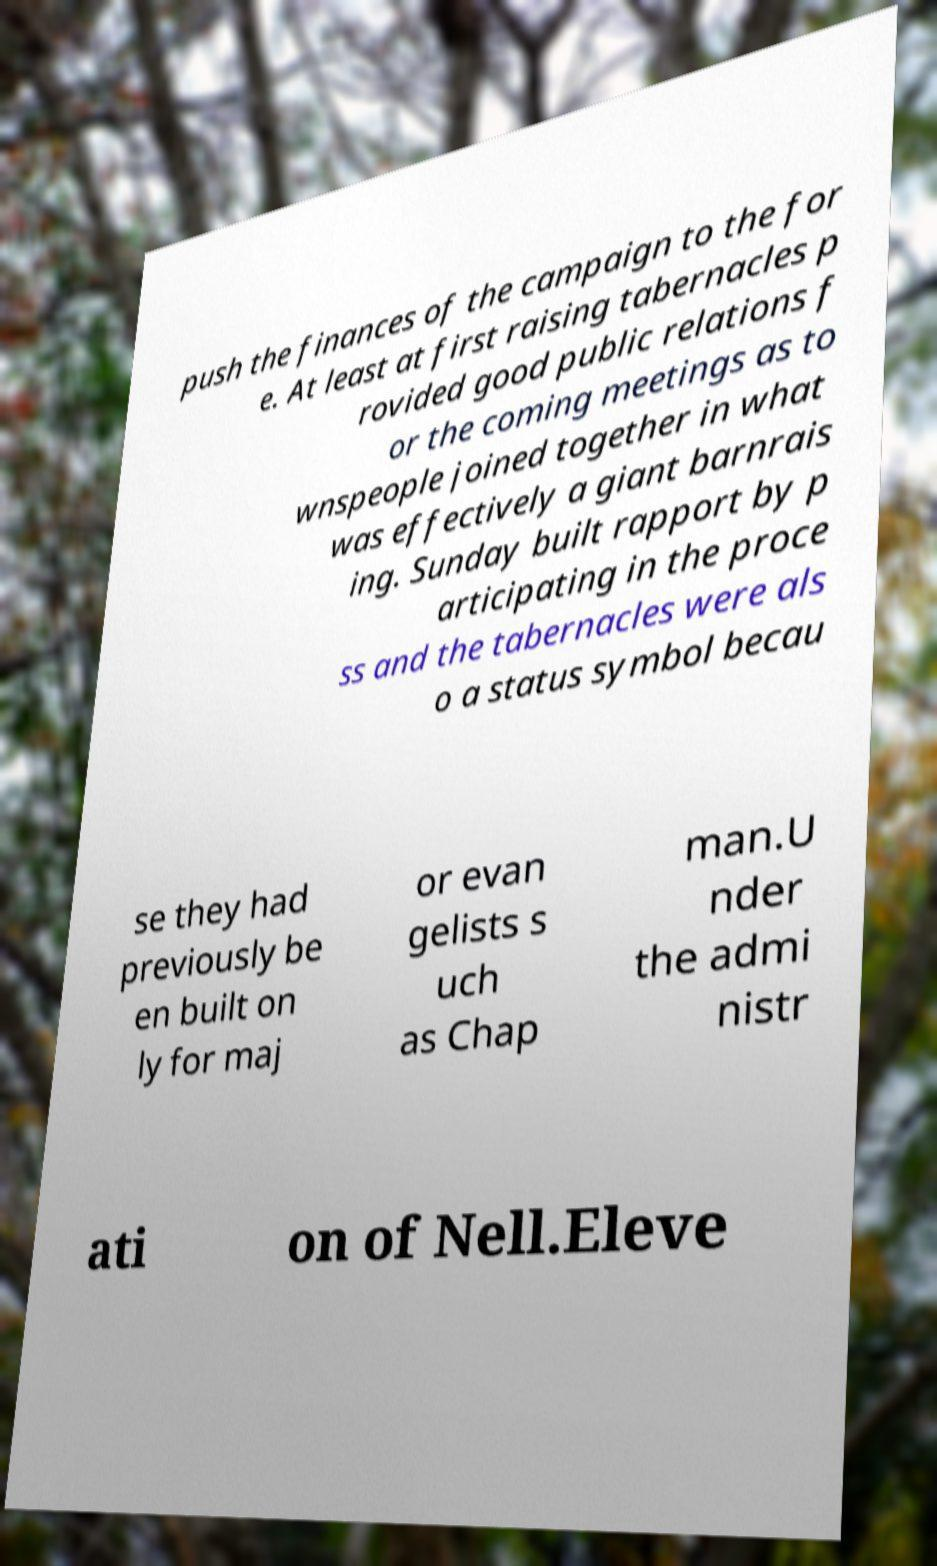Please identify and transcribe the text found in this image. push the finances of the campaign to the for e. At least at first raising tabernacles p rovided good public relations f or the coming meetings as to wnspeople joined together in what was effectively a giant barnrais ing. Sunday built rapport by p articipating in the proce ss and the tabernacles were als o a status symbol becau se they had previously be en built on ly for maj or evan gelists s uch as Chap man.U nder the admi nistr ati on of Nell.Eleve 